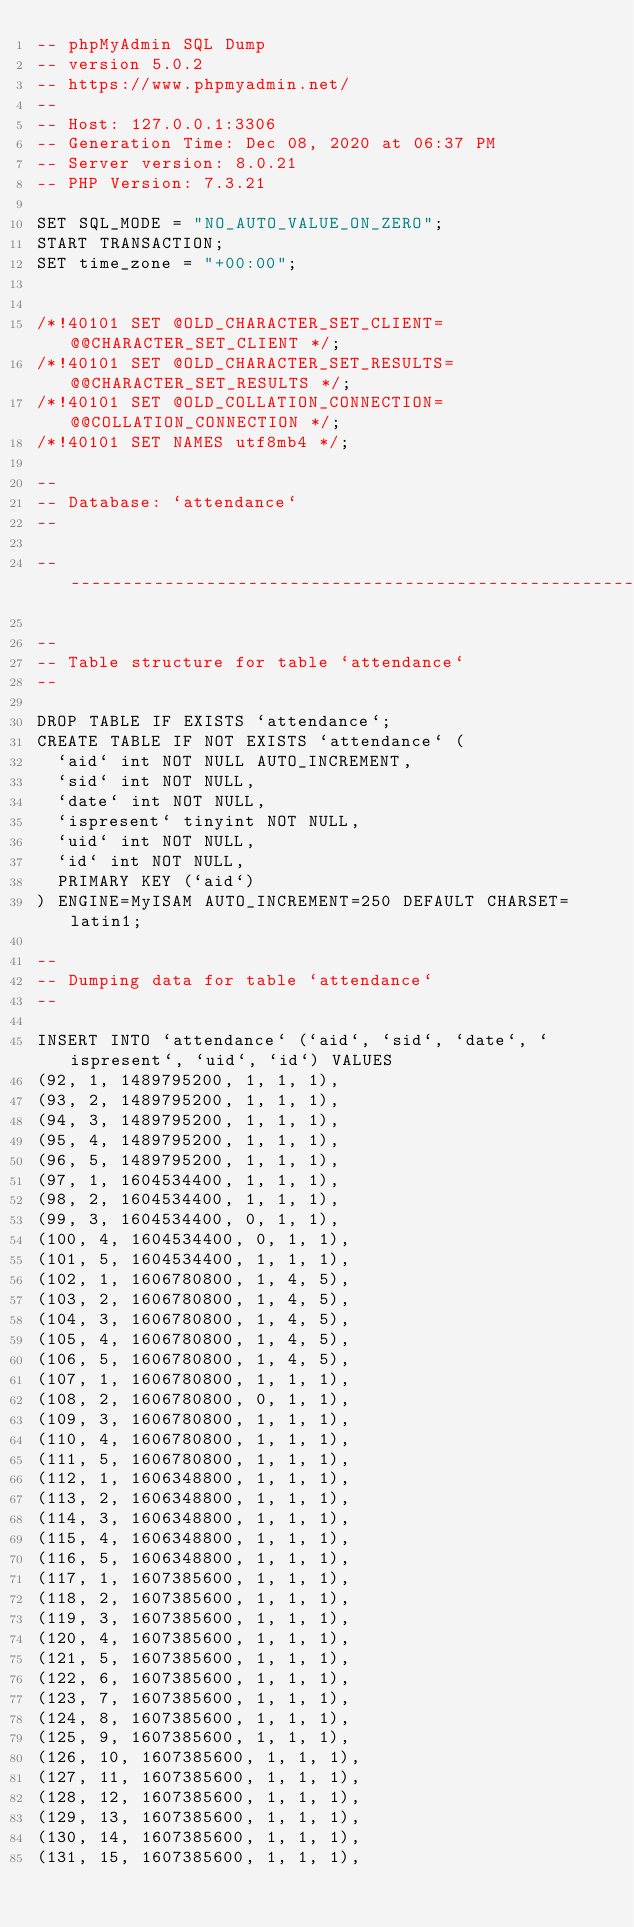<code> <loc_0><loc_0><loc_500><loc_500><_SQL_>-- phpMyAdmin SQL Dump
-- version 5.0.2
-- https://www.phpmyadmin.net/
--
-- Host: 127.0.0.1:3306
-- Generation Time: Dec 08, 2020 at 06:37 PM
-- Server version: 8.0.21
-- PHP Version: 7.3.21

SET SQL_MODE = "NO_AUTO_VALUE_ON_ZERO";
START TRANSACTION;
SET time_zone = "+00:00";


/*!40101 SET @OLD_CHARACTER_SET_CLIENT=@@CHARACTER_SET_CLIENT */;
/*!40101 SET @OLD_CHARACTER_SET_RESULTS=@@CHARACTER_SET_RESULTS */;
/*!40101 SET @OLD_COLLATION_CONNECTION=@@COLLATION_CONNECTION */;
/*!40101 SET NAMES utf8mb4 */;

--
-- Database: `attendance`
--

-- --------------------------------------------------------

--
-- Table structure for table `attendance`
--

DROP TABLE IF EXISTS `attendance`;
CREATE TABLE IF NOT EXISTS `attendance` (
  `aid` int NOT NULL AUTO_INCREMENT,
  `sid` int NOT NULL,
  `date` int NOT NULL,
  `ispresent` tinyint NOT NULL,
  `uid` int NOT NULL,
  `id` int NOT NULL,
  PRIMARY KEY (`aid`)
) ENGINE=MyISAM AUTO_INCREMENT=250 DEFAULT CHARSET=latin1;

--
-- Dumping data for table `attendance`
--

INSERT INTO `attendance` (`aid`, `sid`, `date`, `ispresent`, `uid`, `id`) VALUES
(92, 1, 1489795200, 1, 1, 1),
(93, 2, 1489795200, 1, 1, 1),
(94, 3, 1489795200, 1, 1, 1),
(95, 4, 1489795200, 1, 1, 1),
(96, 5, 1489795200, 1, 1, 1),
(97, 1, 1604534400, 1, 1, 1),
(98, 2, 1604534400, 1, 1, 1),
(99, 3, 1604534400, 0, 1, 1),
(100, 4, 1604534400, 0, 1, 1),
(101, 5, 1604534400, 1, 1, 1),
(102, 1, 1606780800, 1, 4, 5),
(103, 2, 1606780800, 1, 4, 5),
(104, 3, 1606780800, 1, 4, 5),
(105, 4, 1606780800, 1, 4, 5),
(106, 5, 1606780800, 1, 4, 5),
(107, 1, 1606780800, 1, 1, 1),
(108, 2, 1606780800, 0, 1, 1),
(109, 3, 1606780800, 1, 1, 1),
(110, 4, 1606780800, 1, 1, 1),
(111, 5, 1606780800, 1, 1, 1),
(112, 1, 1606348800, 1, 1, 1),
(113, 2, 1606348800, 1, 1, 1),
(114, 3, 1606348800, 1, 1, 1),
(115, 4, 1606348800, 1, 1, 1),
(116, 5, 1606348800, 1, 1, 1),
(117, 1, 1607385600, 1, 1, 1),
(118, 2, 1607385600, 1, 1, 1),
(119, 3, 1607385600, 1, 1, 1),
(120, 4, 1607385600, 1, 1, 1),
(121, 5, 1607385600, 1, 1, 1),
(122, 6, 1607385600, 1, 1, 1),
(123, 7, 1607385600, 1, 1, 1),
(124, 8, 1607385600, 1, 1, 1),
(125, 9, 1607385600, 1, 1, 1),
(126, 10, 1607385600, 1, 1, 1),
(127, 11, 1607385600, 1, 1, 1),
(128, 12, 1607385600, 1, 1, 1),
(129, 13, 1607385600, 1, 1, 1),
(130, 14, 1607385600, 1, 1, 1),
(131, 15, 1607385600, 1, 1, 1),</code> 